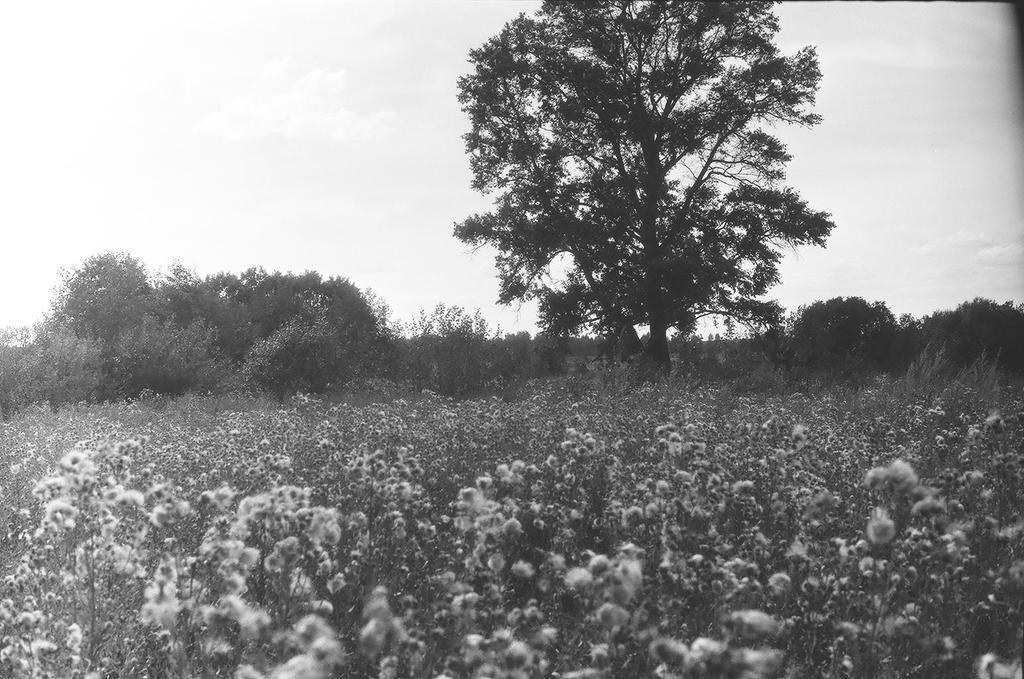Describe this image in one or two sentences. In the image we can see black and white picture of the tree, plants and the sky. 